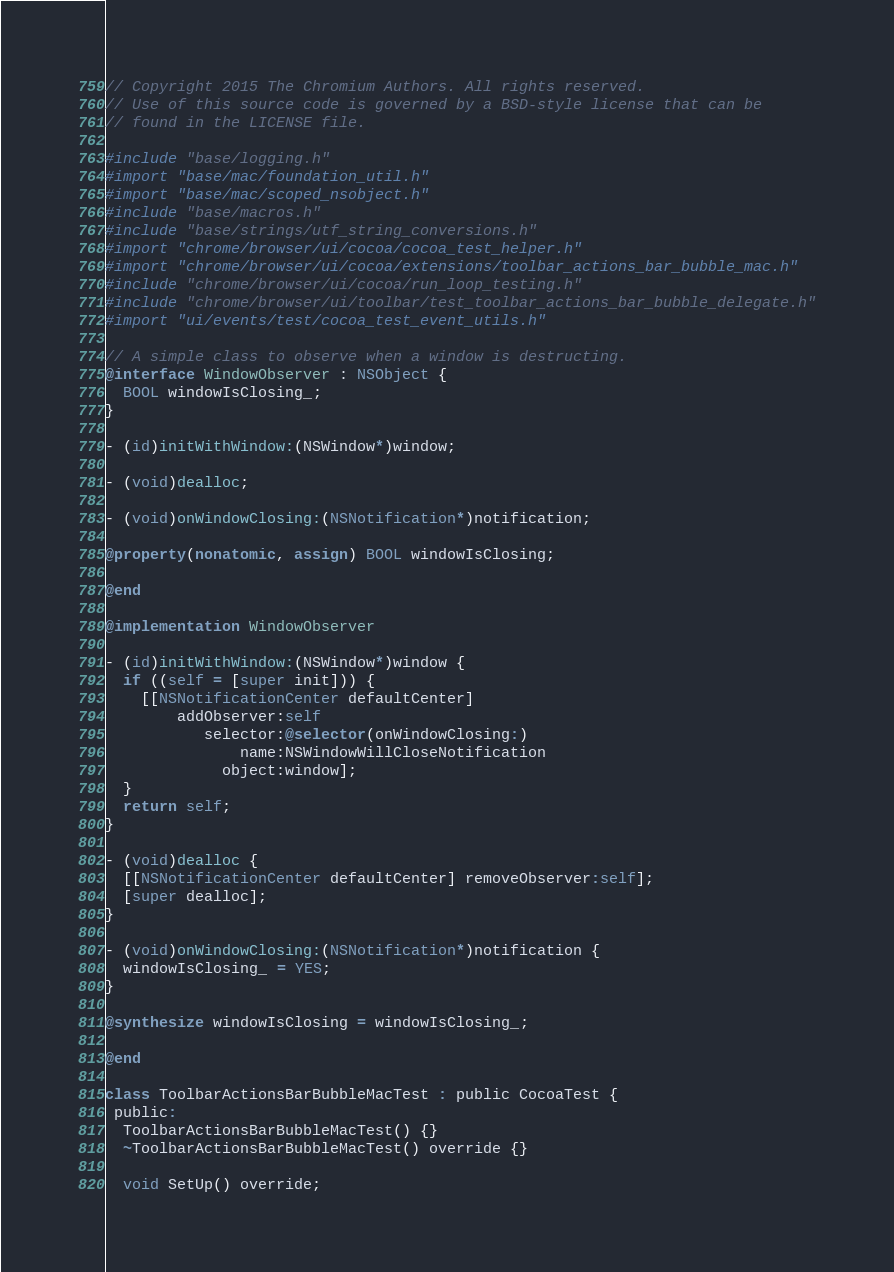Convert code to text. <code><loc_0><loc_0><loc_500><loc_500><_ObjectiveC_>// Copyright 2015 The Chromium Authors. All rights reserved.
// Use of this source code is governed by a BSD-style license that can be
// found in the LICENSE file.

#include "base/logging.h"
#import "base/mac/foundation_util.h"
#import "base/mac/scoped_nsobject.h"
#include "base/macros.h"
#include "base/strings/utf_string_conversions.h"
#import "chrome/browser/ui/cocoa/cocoa_test_helper.h"
#import "chrome/browser/ui/cocoa/extensions/toolbar_actions_bar_bubble_mac.h"
#include "chrome/browser/ui/cocoa/run_loop_testing.h"
#include "chrome/browser/ui/toolbar/test_toolbar_actions_bar_bubble_delegate.h"
#import "ui/events/test/cocoa_test_event_utils.h"

// A simple class to observe when a window is destructing.
@interface WindowObserver : NSObject {
  BOOL windowIsClosing_;
}

- (id)initWithWindow:(NSWindow*)window;

- (void)dealloc;

- (void)onWindowClosing:(NSNotification*)notification;

@property(nonatomic, assign) BOOL windowIsClosing;

@end

@implementation WindowObserver

- (id)initWithWindow:(NSWindow*)window {
  if ((self = [super init])) {
    [[NSNotificationCenter defaultCenter]
        addObserver:self
           selector:@selector(onWindowClosing:)
               name:NSWindowWillCloseNotification
             object:window];
  }
  return self;
}

- (void)dealloc {
  [[NSNotificationCenter defaultCenter] removeObserver:self];
  [super dealloc];
}

- (void)onWindowClosing:(NSNotification*)notification {
  windowIsClosing_ = YES;
}

@synthesize windowIsClosing = windowIsClosing_;

@end

class ToolbarActionsBarBubbleMacTest : public CocoaTest {
 public:
  ToolbarActionsBarBubbleMacTest() {}
  ~ToolbarActionsBarBubbleMacTest() override {}

  void SetUp() override;
</code> 